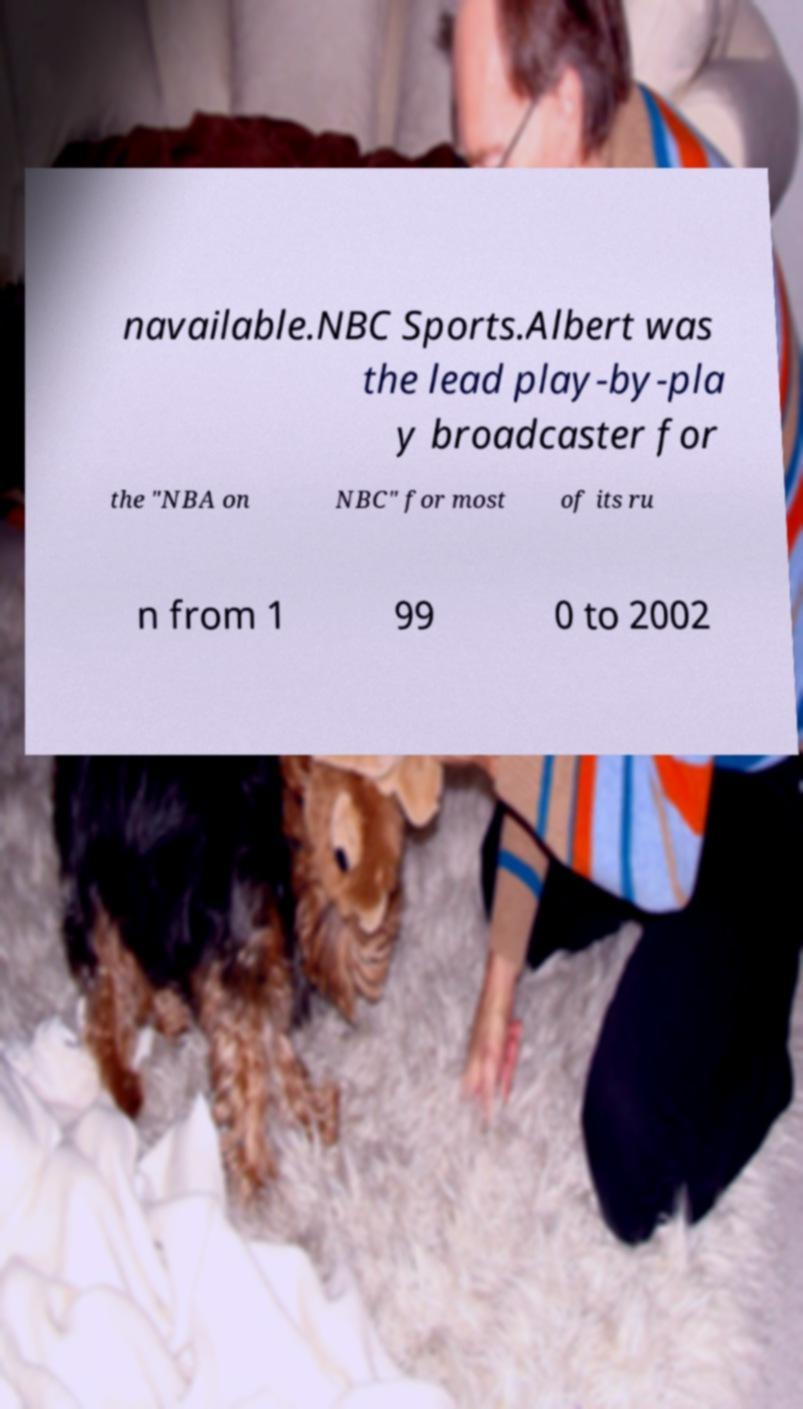Please identify and transcribe the text found in this image. navailable.NBC Sports.Albert was the lead play-by-pla y broadcaster for the "NBA on NBC" for most of its ru n from 1 99 0 to 2002 